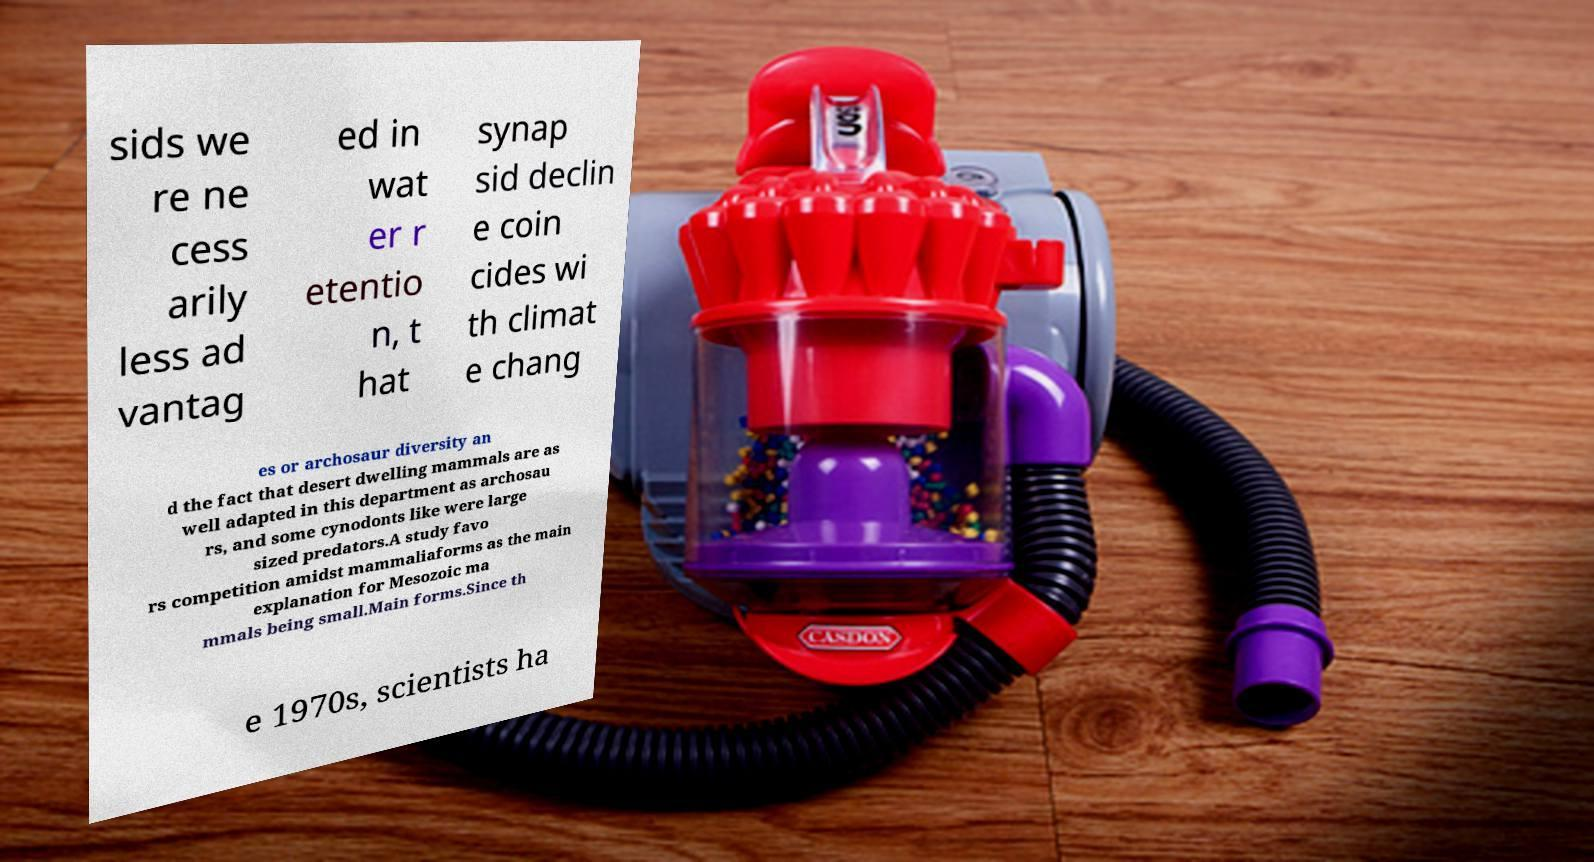Can you accurately transcribe the text from the provided image for me? sids we re ne cess arily less ad vantag ed in wat er r etentio n, t hat synap sid declin e coin cides wi th climat e chang es or archosaur diversity an d the fact that desert dwelling mammals are as well adapted in this department as archosau rs, and some cynodonts like were large sized predators.A study favo rs competition amidst mammaliaforms as the main explanation for Mesozoic ma mmals being small.Main forms.Since th e 1970s, scientists ha 